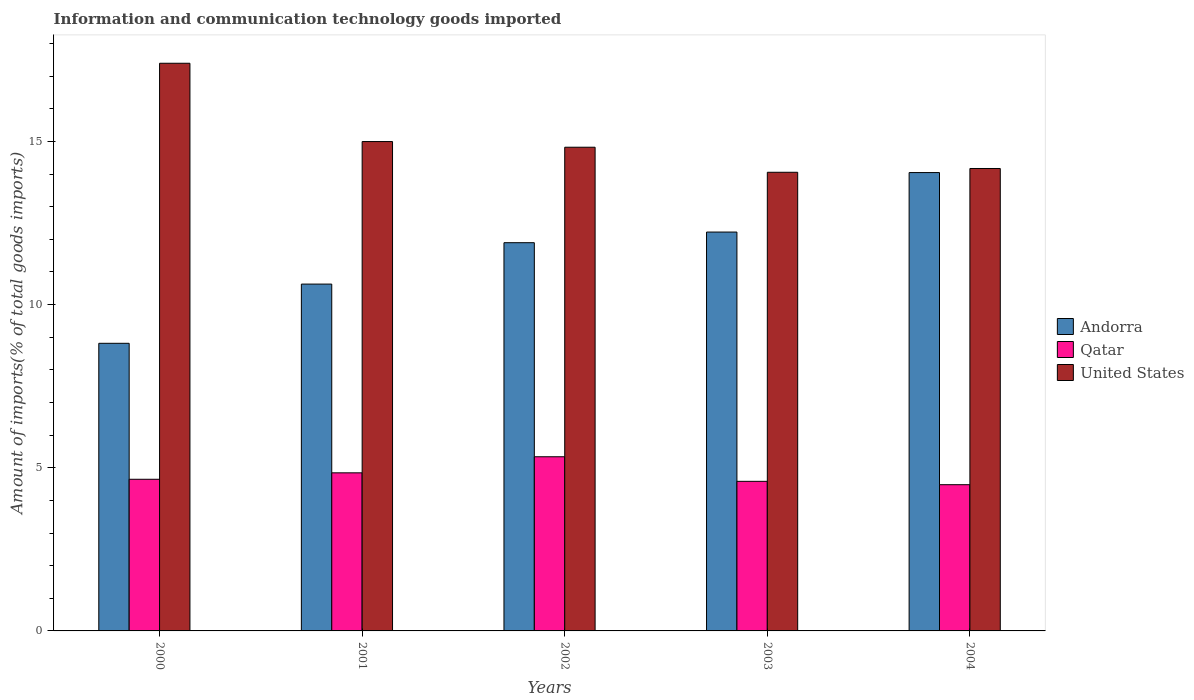What is the label of the 5th group of bars from the left?
Your answer should be compact. 2004. In how many cases, is the number of bars for a given year not equal to the number of legend labels?
Your response must be concise. 0. What is the amount of goods imported in Andorra in 2004?
Keep it short and to the point. 14.05. Across all years, what is the maximum amount of goods imported in Qatar?
Your response must be concise. 5.34. Across all years, what is the minimum amount of goods imported in Qatar?
Give a very brief answer. 4.48. In which year was the amount of goods imported in Qatar maximum?
Your answer should be compact. 2002. In which year was the amount of goods imported in Andorra minimum?
Your response must be concise. 2000. What is the total amount of goods imported in Qatar in the graph?
Provide a short and direct response. 23.89. What is the difference between the amount of goods imported in Qatar in 2000 and that in 2004?
Your response must be concise. 0.17. What is the difference between the amount of goods imported in Andorra in 2000 and the amount of goods imported in Qatar in 2001?
Make the answer very short. 3.97. What is the average amount of goods imported in Qatar per year?
Your answer should be very brief. 4.78. In the year 2000, what is the difference between the amount of goods imported in Andorra and amount of goods imported in Qatar?
Provide a succinct answer. 4.17. What is the ratio of the amount of goods imported in Qatar in 2002 to that in 2003?
Offer a very short reply. 1.16. Is the amount of goods imported in United States in 2000 less than that in 2002?
Offer a very short reply. No. Is the difference between the amount of goods imported in Andorra in 2001 and 2004 greater than the difference between the amount of goods imported in Qatar in 2001 and 2004?
Ensure brevity in your answer.  No. What is the difference between the highest and the second highest amount of goods imported in Qatar?
Offer a terse response. 0.49. What is the difference between the highest and the lowest amount of goods imported in Andorra?
Offer a very short reply. 5.23. What does the 1st bar from the left in 2003 represents?
Keep it short and to the point. Andorra. What does the 1st bar from the right in 2003 represents?
Your response must be concise. United States. Is it the case that in every year, the sum of the amount of goods imported in Qatar and amount of goods imported in Andorra is greater than the amount of goods imported in United States?
Provide a short and direct response. No. How many bars are there?
Provide a succinct answer. 15. What is the difference between two consecutive major ticks on the Y-axis?
Keep it short and to the point. 5. Are the values on the major ticks of Y-axis written in scientific E-notation?
Your response must be concise. No. Does the graph contain any zero values?
Your answer should be very brief. No. Does the graph contain grids?
Ensure brevity in your answer.  No. Where does the legend appear in the graph?
Your answer should be very brief. Center right. What is the title of the graph?
Your answer should be compact. Information and communication technology goods imported. What is the label or title of the X-axis?
Keep it short and to the point. Years. What is the label or title of the Y-axis?
Provide a short and direct response. Amount of imports(% of total goods imports). What is the Amount of imports(% of total goods imports) in Andorra in 2000?
Provide a short and direct response. 8.81. What is the Amount of imports(% of total goods imports) of Qatar in 2000?
Your answer should be compact. 4.65. What is the Amount of imports(% of total goods imports) of United States in 2000?
Offer a terse response. 17.4. What is the Amount of imports(% of total goods imports) of Andorra in 2001?
Your response must be concise. 10.63. What is the Amount of imports(% of total goods imports) in Qatar in 2001?
Keep it short and to the point. 4.84. What is the Amount of imports(% of total goods imports) of United States in 2001?
Make the answer very short. 15. What is the Amount of imports(% of total goods imports) of Andorra in 2002?
Provide a short and direct response. 11.9. What is the Amount of imports(% of total goods imports) of Qatar in 2002?
Your answer should be compact. 5.34. What is the Amount of imports(% of total goods imports) of United States in 2002?
Offer a terse response. 14.82. What is the Amount of imports(% of total goods imports) of Andorra in 2003?
Offer a very short reply. 12.22. What is the Amount of imports(% of total goods imports) in Qatar in 2003?
Offer a very short reply. 4.58. What is the Amount of imports(% of total goods imports) of United States in 2003?
Offer a very short reply. 14.06. What is the Amount of imports(% of total goods imports) of Andorra in 2004?
Offer a very short reply. 14.05. What is the Amount of imports(% of total goods imports) in Qatar in 2004?
Your answer should be compact. 4.48. What is the Amount of imports(% of total goods imports) in United States in 2004?
Your answer should be very brief. 14.17. Across all years, what is the maximum Amount of imports(% of total goods imports) of Andorra?
Your answer should be compact. 14.05. Across all years, what is the maximum Amount of imports(% of total goods imports) of Qatar?
Ensure brevity in your answer.  5.34. Across all years, what is the maximum Amount of imports(% of total goods imports) in United States?
Ensure brevity in your answer.  17.4. Across all years, what is the minimum Amount of imports(% of total goods imports) of Andorra?
Your response must be concise. 8.81. Across all years, what is the minimum Amount of imports(% of total goods imports) of Qatar?
Make the answer very short. 4.48. Across all years, what is the minimum Amount of imports(% of total goods imports) in United States?
Make the answer very short. 14.06. What is the total Amount of imports(% of total goods imports) of Andorra in the graph?
Make the answer very short. 57.61. What is the total Amount of imports(% of total goods imports) in Qatar in the graph?
Keep it short and to the point. 23.89. What is the total Amount of imports(% of total goods imports) in United States in the graph?
Ensure brevity in your answer.  75.44. What is the difference between the Amount of imports(% of total goods imports) in Andorra in 2000 and that in 2001?
Keep it short and to the point. -1.81. What is the difference between the Amount of imports(% of total goods imports) in Qatar in 2000 and that in 2001?
Your response must be concise. -0.2. What is the difference between the Amount of imports(% of total goods imports) in United States in 2000 and that in 2001?
Give a very brief answer. 2.4. What is the difference between the Amount of imports(% of total goods imports) in Andorra in 2000 and that in 2002?
Keep it short and to the point. -3.08. What is the difference between the Amount of imports(% of total goods imports) in Qatar in 2000 and that in 2002?
Keep it short and to the point. -0.69. What is the difference between the Amount of imports(% of total goods imports) in United States in 2000 and that in 2002?
Ensure brevity in your answer.  2.57. What is the difference between the Amount of imports(% of total goods imports) of Andorra in 2000 and that in 2003?
Give a very brief answer. -3.41. What is the difference between the Amount of imports(% of total goods imports) of Qatar in 2000 and that in 2003?
Ensure brevity in your answer.  0.06. What is the difference between the Amount of imports(% of total goods imports) of United States in 2000 and that in 2003?
Provide a short and direct response. 3.34. What is the difference between the Amount of imports(% of total goods imports) in Andorra in 2000 and that in 2004?
Offer a very short reply. -5.23. What is the difference between the Amount of imports(% of total goods imports) in Qatar in 2000 and that in 2004?
Your answer should be very brief. 0.17. What is the difference between the Amount of imports(% of total goods imports) of United States in 2000 and that in 2004?
Keep it short and to the point. 3.22. What is the difference between the Amount of imports(% of total goods imports) in Andorra in 2001 and that in 2002?
Your answer should be compact. -1.27. What is the difference between the Amount of imports(% of total goods imports) of Qatar in 2001 and that in 2002?
Your answer should be very brief. -0.49. What is the difference between the Amount of imports(% of total goods imports) of United States in 2001 and that in 2002?
Offer a very short reply. 0.17. What is the difference between the Amount of imports(% of total goods imports) in Andorra in 2001 and that in 2003?
Keep it short and to the point. -1.59. What is the difference between the Amount of imports(% of total goods imports) in Qatar in 2001 and that in 2003?
Give a very brief answer. 0.26. What is the difference between the Amount of imports(% of total goods imports) in United States in 2001 and that in 2003?
Your answer should be compact. 0.94. What is the difference between the Amount of imports(% of total goods imports) of Andorra in 2001 and that in 2004?
Ensure brevity in your answer.  -3.42. What is the difference between the Amount of imports(% of total goods imports) in Qatar in 2001 and that in 2004?
Your answer should be very brief. 0.36. What is the difference between the Amount of imports(% of total goods imports) in United States in 2001 and that in 2004?
Provide a succinct answer. 0.83. What is the difference between the Amount of imports(% of total goods imports) of Andorra in 2002 and that in 2003?
Ensure brevity in your answer.  -0.33. What is the difference between the Amount of imports(% of total goods imports) of Qatar in 2002 and that in 2003?
Provide a short and direct response. 0.75. What is the difference between the Amount of imports(% of total goods imports) of United States in 2002 and that in 2003?
Your answer should be very brief. 0.77. What is the difference between the Amount of imports(% of total goods imports) of Andorra in 2002 and that in 2004?
Provide a succinct answer. -2.15. What is the difference between the Amount of imports(% of total goods imports) of Qatar in 2002 and that in 2004?
Make the answer very short. 0.86. What is the difference between the Amount of imports(% of total goods imports) in United States in 2002 and that in 2004?
Offer a terse response. 0.65. What is the difference between the Amount of imports(% of total goods imports) of Andorra in 2003 and that in 2004?
Provide a succinct answer. -1.82. What is the difference between the Amount of imports(% of total goods imports) of Qatar in 2003 and that in 2004?
Make the answer very short. 0.1. What is the difference between the Amount of imports(% of total goods imports) in United States in 2003 and that in 2004?
Ensure brevity in your answer.  -0.12. What is the difference between the Amount of imports(% of total goods imports) of Andorra in 2000 and the Amount of imports(% of total goods imports) of Qatar in 2001?
Make the answer very short. 3.97. What is the difference between the Amount of imports(% of total goods imports) in Andorra in 2000 and the Amount of imports(% of total goods imports) in United States in 2001?
Provide a short and direct response. -6.18. What is the difference between the Amount of imports(% of total goods imports) of Qatar in 2000 and the Amount of imports(% of total goods imports) of United States in 2001?
Make the answer very short. -10.35. What is the difference between the Amount of imports(% of total goods imports) in Andorra in 2000 and the Amount of imports(% of total goods imports) in Qatar in 2002?
Give a very brief answer. 3.48. What is the difference between the Amount of imports(% of total goods imports) in Andorra in 2000 and the Amount of imports(% of total goods imports) in United States in 2002?
Make the answer very short. -6.01. What is the difference between the Amount of imports(% of total goods imports) of Qatar in 2000 and the Amount of imports(% of total goods imports) of United States in 2002?
Make the answer very short. -10.18. What is the difference between the Amount of imports(% of total goods imports) in Andorra in 2000 and the Amount of imports(% of total goods imports) in Qatar in 2003?
Make the answer very short. 4.23. What is the difference between the Amount of imports(% of total goods imports) in Andorra in 2000 and the Amount of imports(% of total goods imports) in United States in 2003?
Ensure brevity in your answer.  -5.24. What is the difference between the Amount of imports(% of total goods imports) of Qatar in 2000 and the Amount of imports(% of total goods imports) of United States in 2003?
Your answer should be very brief. -9.41. What is the difference between the Amount of imports(% of total goods imports) in Andorra in 2000 and the Amount of imports(% of total goods imports) in Qatar in 2004?
Your answer should be compact. 4.33. What is the difference between the Amount of imports(% of total goods imports) of Andorra in 2000 and the Amount of imports(% of total goods imports) of United States in 2004?
Ensure brevity in your answer.  -5.36. What is the difference between the Amount of imports(% of total goods imports) of Qatar in 2000 and the Amount of imports(% of total goods imports) of United States in 2004?
Provide a succinct answer. -9.52. What is the difference between the Amount of imports(% of total goods imports) of Andorra in 2001 and the Amount of imports(% of total goods imports) of Qatar in 2002?
Keep it short and to the point. 5.29. What is the difference between the Amount of imports(% of total goods imports) in Andorra in 2001 and the Amount of imports(% of total goods imports) in United States in 2002?
Keep it short and to the point. -4.19. What is the difference between the Amount of imports(% of total goods imports) in Qatar in 2001 and the Amount of imports(% of total goods imports) in United States in 2002?
Provide a succinct answer. -9.98. What is the difference between the Amount of imports(% of total goods imports) in Andorra in 2001 and the Amount of imports(% of total goods imports) in Qatar in 2003?
Keep it short and to the point. 6.04. What is the difference between the Amount of imports(% of total goods imports) of Andorra in 2001 and the Amount of imports(% of total goods imports) of United States in 2003?
Ensure brevity in your answer.  -3.43. What is the difference between the Amount of imports(% of total goods imports) of Qatar in 2001 and the Amount of imports(% of total goods imports) of United States in 2003?
Your response must be concise. -9.21. What is the difference between the Amount of imports(% of total goods imports) of Andorra in 2001 and the Amount of imports(% of total goods imports) of Qatar in 2004?
Keep it short and to the point. 6.15. What is the difference between the Amount of imports(% of total goods imports) of Andorra in 2001 and the Amount of imports(% of total goods imports) of United States in 2004?
Your response must be concise. -3.54. What is the difference between the Amount of imports(% of total goods imports) of Qatar in 2001 and the Amount of imports(% of total goods imports) of United States in 2004?
Provide a short and direct response. -9.33. What is the difference between the Amount of imports(% of total goods imports) of Andorra in 2002 and the Amount of imports(% of total goods imports) of Qatar in 2003?
Give a very brief answer. 7.31. What is the difference between the Amount of imports(% of total goods imports) of Andorra in 2002 and the Amount of imports(% of total goods imports) of United States in 2003?
Your answer should be compact. -2.16. What is the difference between the Amount of imports(% of total goods imports) in Qatar in 2002 and the Amount of imports(% of total goods imports) in United States in 2003?
Offer a very short reply. -8.72. What is the difference between the Amount of imports(% of total goods imports) of Andorra in 2002 and the Amount of imports(% of total goods imports) of Qatar in 2004?
Keep it short and to the point. 7.42. What is the difference between the Amount of imports(% of total goods imports) of Andorra in 2002 and the Amount of imports(% of total goods imports) of United States in 2004?
Offer a very short reply. -2.27. What is the difference between the Amount of imports(% of total goods imports) of Qatar in 2002 and the Amount of imports(% of total goods imports) of United States in 2004?
Give a very brief answer. -8.83. What is the difference between the Amount of imports(% of total goods imports) of Andorra in 2003 and the Amount of imports(% of total goods imports) of Qatar in 2004?
Ensure brevity in your answer.  7.74. What is the difference between the Amount of imports(% of total goods imports) in Andorra in 2003 and the Amount of imports(% of total goods imports) in United States in 2004?
Make the answer very short. -1.95. What is the difference between the Amount of imports(% of total goods imports) of Qatar in 2003 and the Amount of imports(% of total goods imports) of United States in 2004?
Make the answer very short. -9.59. What is the average Amount of imports(% of total goods imports) of Andorra per year?
Give a very brief answer. 11.52. What is the average Amount of imports(% of total goods imports) of Qatar per year?
Offer a terse response. 4.78. What is the average Amount of imports(% of total goods imports) of United States per year?
Provide a short and direct response. 15.09. In the year 2000, what is the difference between the Amount of imports(% of total goods imports) of Andorra and Amount of imports(% of total goods imports) of Qatar?
Provide a succinct answer. 4.17. In the year 2000, what is the difference between the Amount of imports(% of total goods imports) in Andorra and Amount of imports(% of total goods imports) in United States?
Your answer should be compact. -8.58. In the year 2000, what is the difference between the Amount of imports(% of total goods imports) of Qatar and Amount of imports(% of total goods imports) of United States?
Give a very brief answer. -12.75. In the year 2001, what is the difference between the Amount of imports(% of total goods imports) of Andorra and Amount of imports(% of total goods imports) of Qatar?
Keep it short and to the point. 5.78. In the year 2001, what is the difference between the Amount of imports(% of total goods imports) of Andorra and Amount of imports(% of total goods imports) of United States?
Give a very brief answer. -4.37. In the year 2001, what is the difference between the Amount of imports(% of total goods imports) of Qatar and Amount of imports(% of total goods imports) of United States?
Ensure brevity in your answer.  -10.15. In the year 2002, what is the difference between the Amount of imports(% of total goods imports) of Andorra and Amount of imports(% of total goods imports) of Qatar?
Ensure brevity in your answer.  6.56. In the year 2002, what is the difference between the Amount of imports(% of total goods imports) in Andorra and Amount of imports(% of total goods imports) in United States?
Offer a terse response. -2.93. In the year 2002, what is the difference between the Amount of imports(% of total goods imports) in Qatar and Amount of imports(% of total goods imports) in United States?
Your response must be concise. -9.49. In the year 2003, what is the difference between the Amount of imports(% of total goods imports) in Andorra and Amount of imports(% of total goods imports) in Qatar?
Offer a very short reply. 7.64. In the year 2003, what is the difference between the Amount of imports(% of total goods imports) in Andorra and Amount of imports(% of total goods imports) in United States?
Provide a succinct answer. -1.83. In the year 2003, what is the difference between the Amount of imports(% of total goods imports) in Qatar and Amount of imports(% of total goods imports) in United States?
Give a very brief answer. -9.47. In the year 2004, what is the difference between the Amount of imports(% of total goods imports) of Andorra and Amount of imports(% of total goods imports) of Qatar?
Your response must be concise. 9.57. In the year 2004, what is the difference between the Amount of imports(% of total goods imports) of Andorra and Amount of imports(% of total goods imports) of United States?
Make the answer very short. -0.12. In the year 2004, what is the difference between the Amount of imports(% of total goods imports) in Qatar and Amount of imports(% of total goods imports) in United States?
Give a very brief answer. -9.69. What is the ratio of the Amount of imports(% of total goods imports) of Andorra in 2000 to that in 2001?
Offer a terse response. 0.83. What is the ratio of the Amount of imports(% of total goods imports) in Qatar in 2000 to that in 2001?
Make the answer very short. 0.96. What is the ratio of the Amount of imports(% of total goods imports) of United States in 2000 to that in 2001?
Ensure brevity in your answer.  1.16. What is the ratio of the Amount of imports(% of total goods imports) in Andorra in 2000 to that in 2002?
Ensure brevity in your answer.  0.74. What is the ratio of the Amount of imports(% of total goods imports) in Qatar in 2000 to that in 2002?
Give a very brief answer. 0.87. What is the ratio of the Amount of imports(% of total goods imports) in United States in 2000 to that in 2002?
Your answer should be compact. 1.17. What is the ratio of the Amount of imports(% of total goods imports) of Andorra in 2000 to that in 2003?
Keep it short and to the point. 0.72. What is the ratio of the Amount of imports(% of total goods imports) in Qatar in 2000 to that in 2003?
Your answer should be compact. 1.01. What is the ratio of the Amount of imports(% of total goods imports) of United States in 2000 to that in 2003?
Keep it short and to the point. 1.24. What is the ratio of the Amount of imports(% of total goods imports) in Andorra in 2000 to that in 2004?
Your answer should be compact. 0.63. What is the ratio of the Amount of imports(% of total goods imports) in Qatar in 2000 to that in 2004?
Your response must be concise. 1.04. What is the ratio of the Amount of imports(% of total goods imports) of United States in 2000 to that in 2004?
Make the answer very short. 1.23. What is the ratio of the Amount of imports(% of total goods imports) in Andorra in 2001 to that in 2002?
Offer a terse response. 0.89. What is the ratio of the Amount of imports(% of total goods imports) of Qatar in 2001 to that in 2002?
Provide a succinct answer. 0.91. What is the ratio of the Amount of imports(% of total goods imports) in United States in 2001 to that in 2002?
Give a very brief answer. 1.01. What is the ratio of the Amount of imports(% of total goods imports) of Andorra in 2001 to that in 2003?
Give a very brief answer. 0.87. What is the ratio of the Amount of imports(% of total goods imports) in Qatar in 2001 to that in 2003?
Offer a very short reply. 1.06. What is the ratio of the Amount of imports(% of total goods imports) of United States in 2001 to that in 2003?
Your response must be concise. 1.07. What is the ratio of the Amount of imports(% of total goods imports) in Andorra in 2001 to that in 2004?
Offer a very short reply. 0.76. What is the ratio of the Amount of imports(% of total goods imports) of Qatar in 2001 to that in 2004?
Keep it short and to the point. 1.08. What is the ratio of the Amount of imports(% of total goods imports) of United States in 2001 to that in 2004?
Your answer should be compact. 1.06. What is the ratio of the Amount of imports(% of total goods imports) of Andorra in 2002 to that in 2003?
Your answer should be compact. 0.97. What is the ratio of the Amount of imports(% of total goods imports) of Qatar in 2002 to that in 2003?
Offer a terse response. 1.16. What is the ratio of the Amount of imports(% of total goods imports) of United States in 2002 to that in 2003?
Your answer should be compact. 1.05. What is the ratio of the Amount of imports(% of total goods imports) of Andorra in 2002 to that in 2004?
Ensure brevity in your answer.  0.85. What is the ratio of the Amount of imports(% of total goods imports) of Qatar in 2002 to that in 2004?
Your answer should be compact. 1.19. What is the ratio of the Amount of imports(% of total goods imports) in United States in 2002 to that in 2004?
Ensure brevity in your answer.  1.05. What is the ratio of the Amount of imports(% of total goods imports) in Andorra in 2003 to that in 2004?
Offer a very short reply. 0.87. What is the ratio of the Amount of imports(% of total goods imports) in Qatar in 2003 to that in 2004?
Keep it short and to the point. 1.02. What is the ratio of the Amount of imports(% of total goods imports) of United States in 2003 to that in 2004?
Provide a succinct answer. 0.99. What is the difference between the highest and the second highest Amount of imports(% of total goods imports) in Andorra?
Your response must be concise. 1.82. What is the difference between the highest and the second highest Amount of imports(% of total goods imports) of Qatar?
Ensure brevity in your answer.  0.49. What is the difference between the highest and the second highest Amount of imports(% of total goods imports) of United States?
Make the answer very short. 2.4. What is the difference between the highest and the lowest Amount of imports(% of total goods imports) of Andorra?
Give a very brief answer. 5.23. What is the difference between the highest and the lowest Amount of imports(% of total goods imports) in Qatar?
Offer a very short reply. 0.86. What is the difference between the highest and the lowest Amount of imports(% of total goods imports) of United States?
Give a very brief answer. 3.34. 